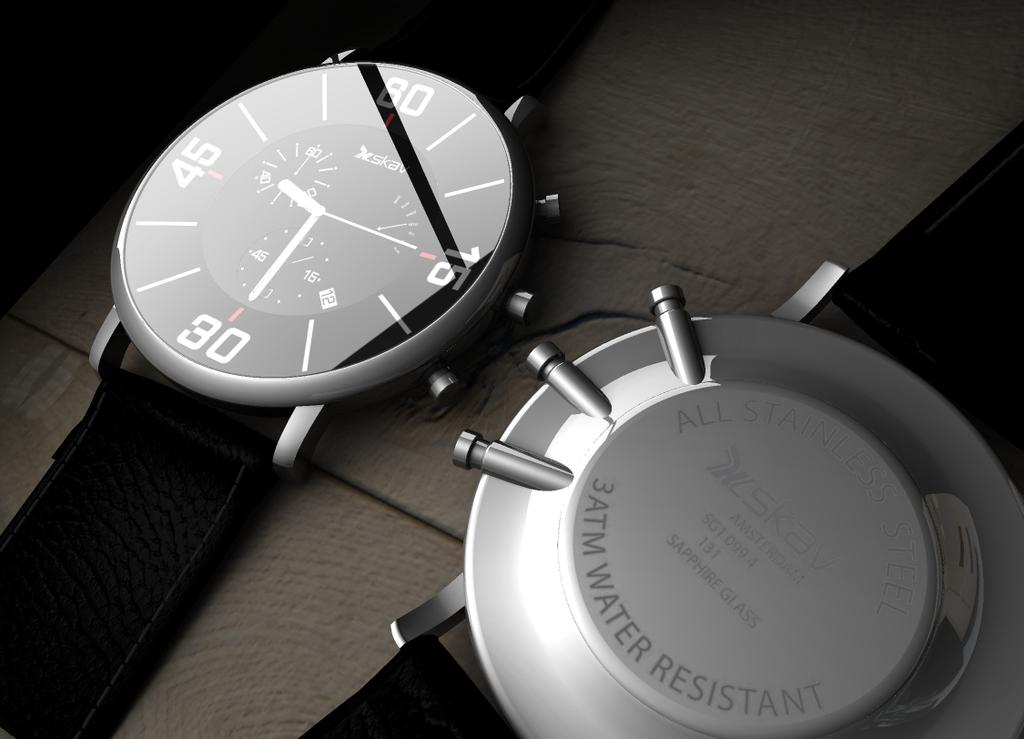<image>
Create a compact narrative representing the image presented. a front and back shot of a watch with 'water resistant' on the back. 